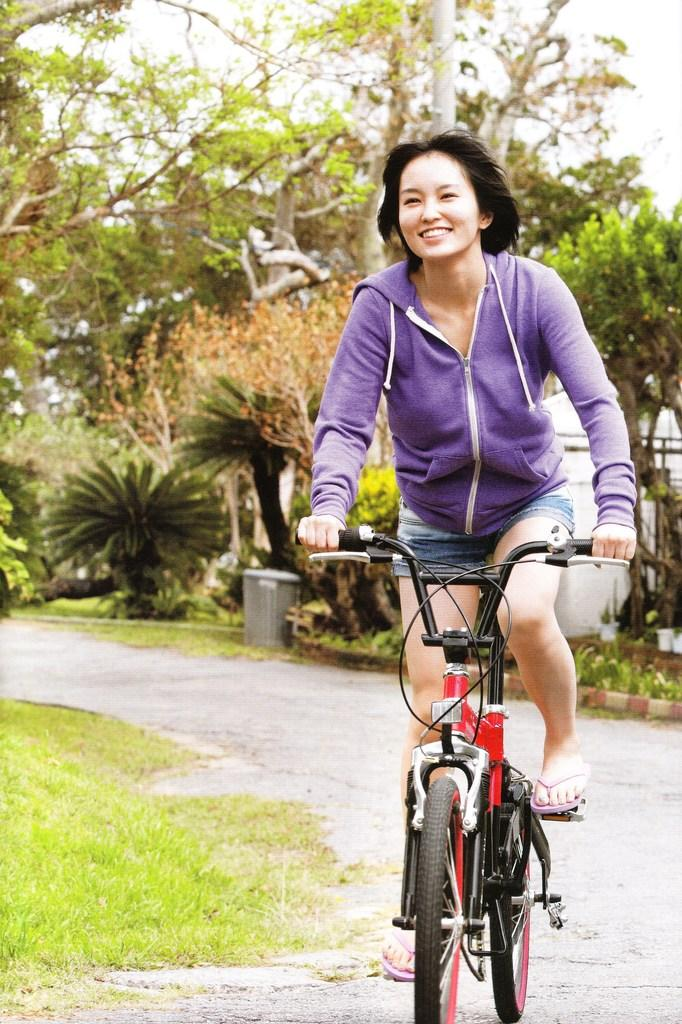Who is the main subject in the image? There is a woman in the image. What is the woman doing in the image? The woman is riding a bicycle. What type of natural environment can be seen in the image? There are trees and plants visible in the image. How many chairs are visible in the image? There are no chairs present in the image. What type of rock is the woman using to ride the bicycle? The woman is not riding on a rock; she is riding a bicycle, which is a separate object. 